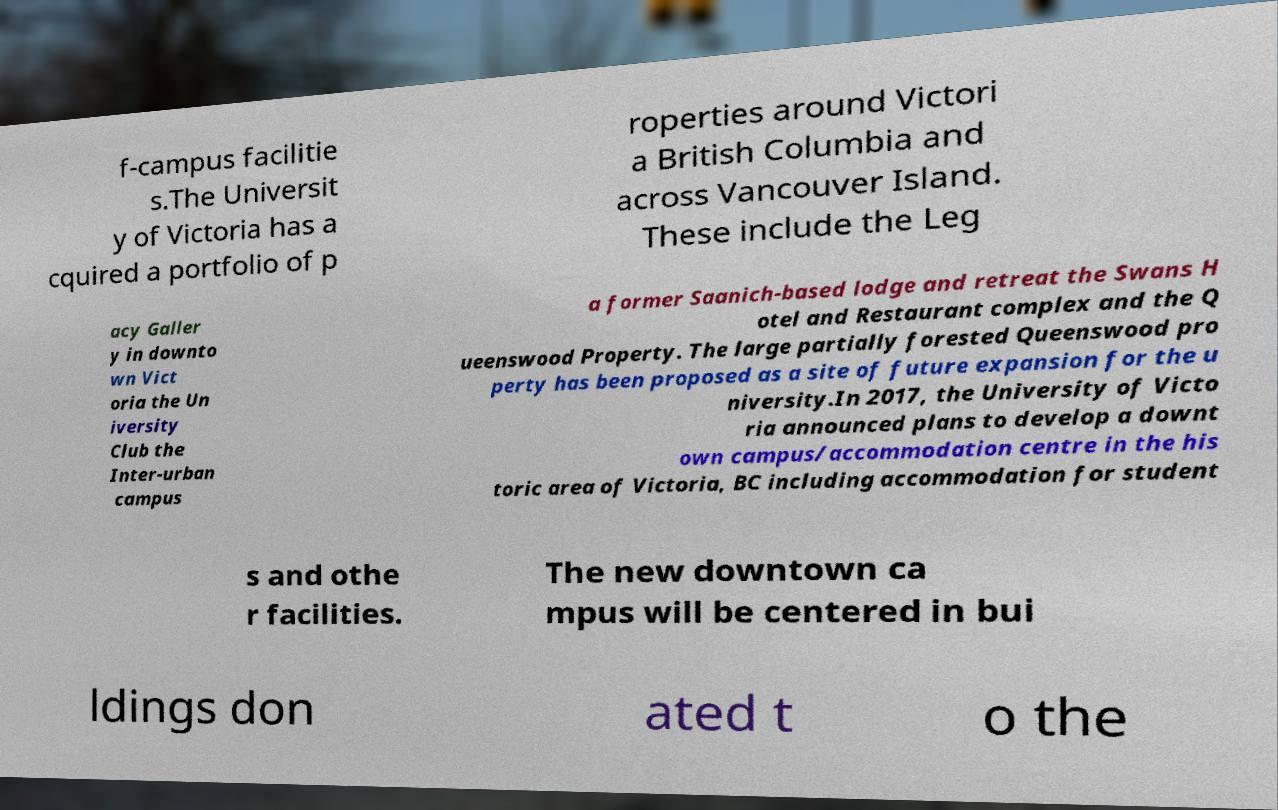Can you accurately transcribe the text from the provided image for me? f-campus facilitie s.The Universit y of Victoria has a cquired a portfolio of p roperties around Victori a British Columbia and across Vancouver Island. These include the Leg acy Galler y in downto wn Vict oria the Un iversity Club the Inter-urban campus a former Saanich-based lodge and retreat the Swans H otel and Restaurant complex and the Q ueenswood Property. The large partially forested Queenswood pro perty has been proposed as a site of future expansion for the u niversity.In 2017, the University of Victo ria announced plans to develop a downt own campus/accommodation centre in the his toric area of Victoria, BC including accommodation for student s and othe r facilities. The new downtown ca mpus will be centered in bui ldings don ated t o the 